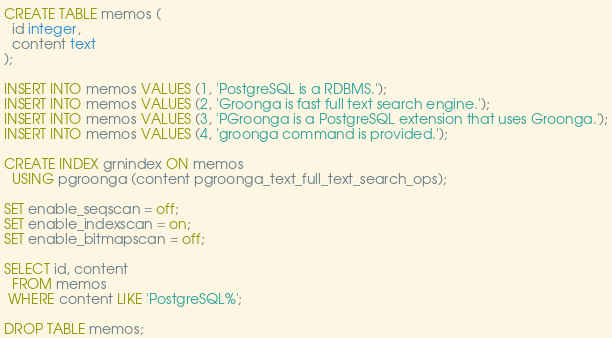Convert code to text. <code><loc_0><loc_0><loc_500><loc_500><_SQL_>CREATE TABLE memos (
  id integer,
  content text
);

INSERT INTO memos VALUES (1, 'PostgreSQL is a RDBMS.');
INSERT INTO memos VALUES (2, 'Groonga is fast full text search engine.');
INSERT INTO memos VALUES (3, 'PGroonga is a PostgreSQL extension that uses Groonga.');
INSERT INTO memos VALUES (4, 'groonga command is provided.');

CREATE INDEX grnindex ON memos
  USING pgroonga (content pgroonga_text_full_text_search_ops);

SET enable_seqscan = off;
SET enable_indexscan = on;
SET enable_bitmapscan = off;

SELECT id, content
  FROM memos
 WHERE content LIKE 'PostgreSQL%';

DROP TABLE memos;
</code> 